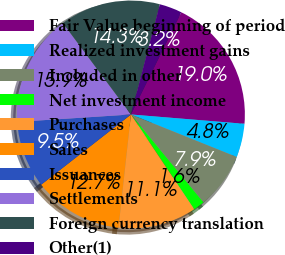Convert chart. <chart><loc_0><loc_0><loc_500><loc_500><pie_chart><fcel>Fair Value beginning of period<fcel>Realized investment gains<fcel>Included in other<fcel>Net investment income<fcel>Purchases<fcel>Sales<fcel>Issuances<fcel>Settlements<fcel>Foreign currency translation<fcel>Other(1)<nl><fcel>19.02%<fcel>4.78%<fcel>7.94%<fcel>1.61%<fcel>11.11%<fcel>12.69%<fcel>9.53%<fcel>15.85%<fcel>14.27%<fcel>3.2%<nl></chart> 